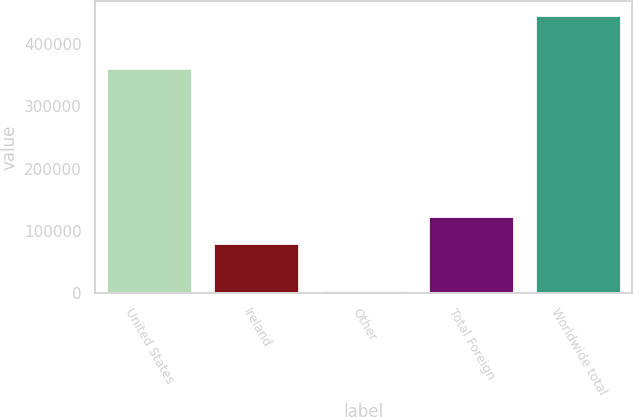Convert chart. <chart><loc_0><loc_0><loc_500><loc_500><bar_chart><fcel>United States<fcel>Ireland<fcel>Other<fcel>Total Foreign<fcel>Worldwide total<nl><fcel>361058<fcel>80365<fcel>5318<fcel>124507<fcel>446741<nl></chart> 